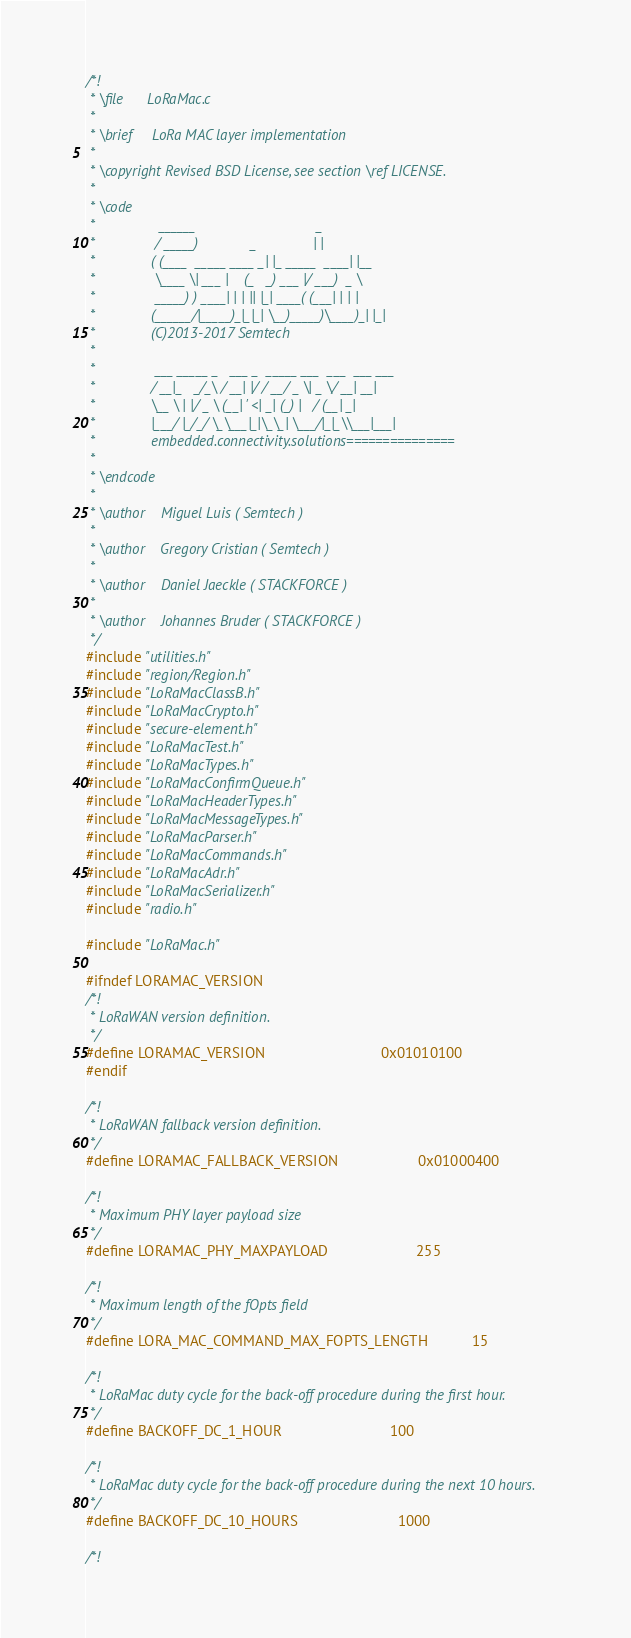<code> <loc_0><loc_0><loc_500><loc_500><_C_>/*!
 * \file      LoRaMac.c
 *
 * \brief     LoRa MAC layer implementation
 *
 * \copyright Revised BSD License, see section \ref LICENSE.
 *
 * \code
 *                ______                              _
 *               / _____)             _              | |
 *              ( (____  _____ ____ _| |_ _____  ____| |__
 *               \____ \| ___ |    (_   _) ___ |/ ___)  _ \
 *               _____) ) ____| | | || |_| ____( (___| | | |
 *              (______/|_____)_|_|_| \__)_____)\____)_| |_|
 *              (C)2013-2017 Semtech
 *
 *               ___ _____ _   ___ _  _____ ___  ___  ___ ___
 *              / __|_   _/_\ / __| |/ / __/ _ \| _ \/ __| __|
 *              \__ \ | |/ _ \ (__| ' <| _| (_) |   / (__| _|
 *              |___/ |_/_/ \_\___|_|\_\_| \___/|_|_\\___|___|
 *              embedded.connectivity.solutions===============
 *
 * \endcode
 *
 * \author    Miguel Luis ( Semtech )
 *
 * \author    Gregory Cristian ( Semtech )
 *
 * \author    Daniel Jaeckle ( STACKFORCE )
 *
 * \author    Johannes Bruder ( STACKFORCE )
 */
#include "utilities.h"
#include "region/Region.h"
#include "LoRaMacClassB.h"
#include "LoRaMacCrypto.h"
#include "secure-element.h"
#include "LoRaMacTest.h"
#include "LoRaMacTypes.h"
#include "LoRaMacConfirmQueue.h"
#include "LoRaMacHeaderTypes.h"
#include "LoRaMacMessageTypes.h"
#include "LoRaMacParser.h"
#include "LoRaMacCommands.h"
#include "LoRaMacAdr.h"
#include "LoRaMacSerializer.h"
#include "radio.h"

#include "LoRaMac.h"

#ifndef LORAMAC_VERSION
/*!
 * LoRaWAN version definition.
 */
#define LORAMAC_VERSION                             0x01010100
#endif

/*!
 * LoRaWAN fallback version definition.
 */
#define LORAMAC_FALLBACK_VERSION                    0x01000400

/*!
 * Maximum PHY layer payload size
 */
#define LORAMAC_PHY_MAXPAYLOAD                      255

/*!
 * Maximum length of the fOpts field
 */
#define LORA_MAC_COMMAND_MAX_FOPTS_LENGTH           15

/*!
 * LoRaMac duty cycle for the back-off procedure during the first hour.
 */
#define BACKOFF_DC_1_HOUR                           100

/*!
 * LoRaMac duty cycle for the back-off procedure during the next 10 hours.
 */
#define BACKOFF_DC_10_HOURS                         1000

/*!</code> 